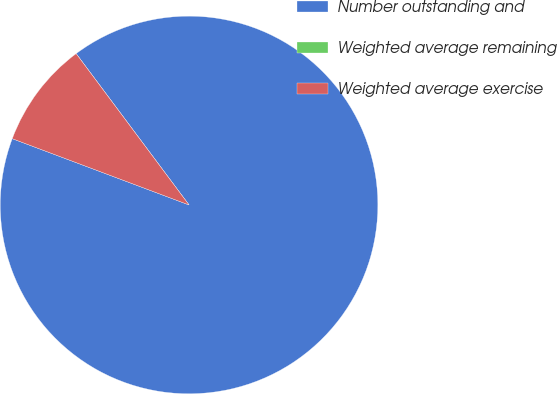<chart> <loc_0><loc_0><loc_500><loc_500><pie_chart><fcel>Number outstanding and<fcel>Weighted average remaining<fcel>Weighted average exercise<nl><fcel>90.91%<fcel>0.0%<fcel>9.09%<nl></chart> 